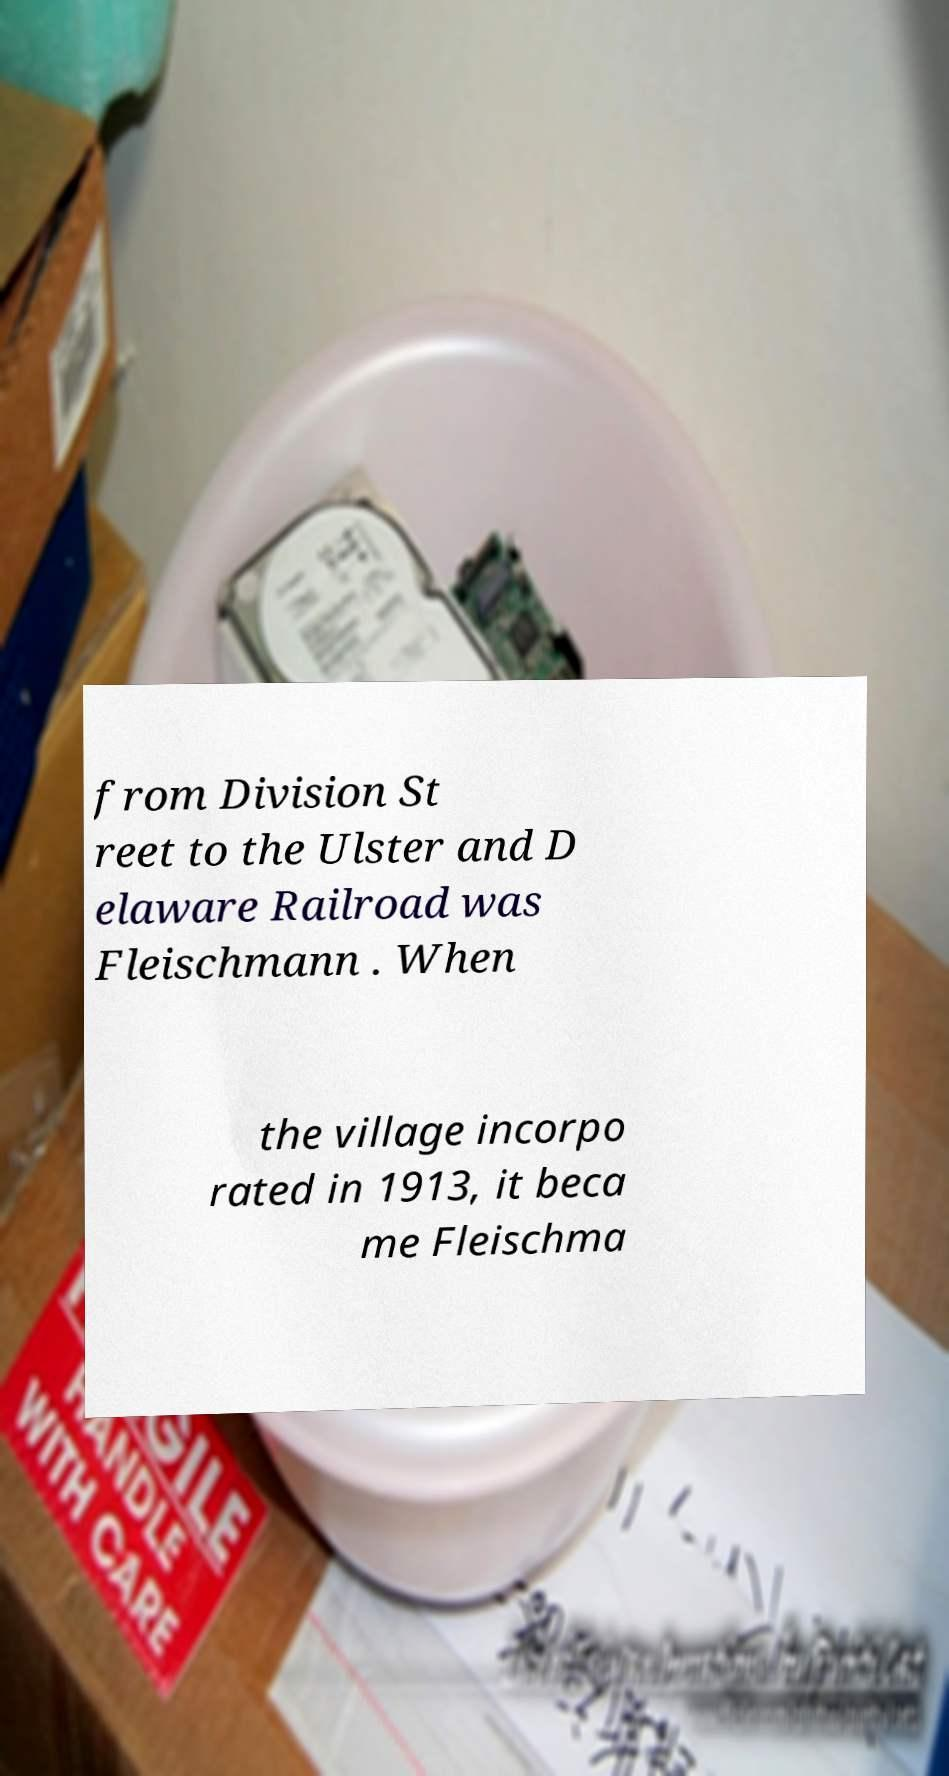I need the written content from this picture converted into text. Can you do that? from Division St reet to the Ulster and D elaware Railroad was Fleischmann . When the village incorpo rated in 1913, it beca me Fleischma 